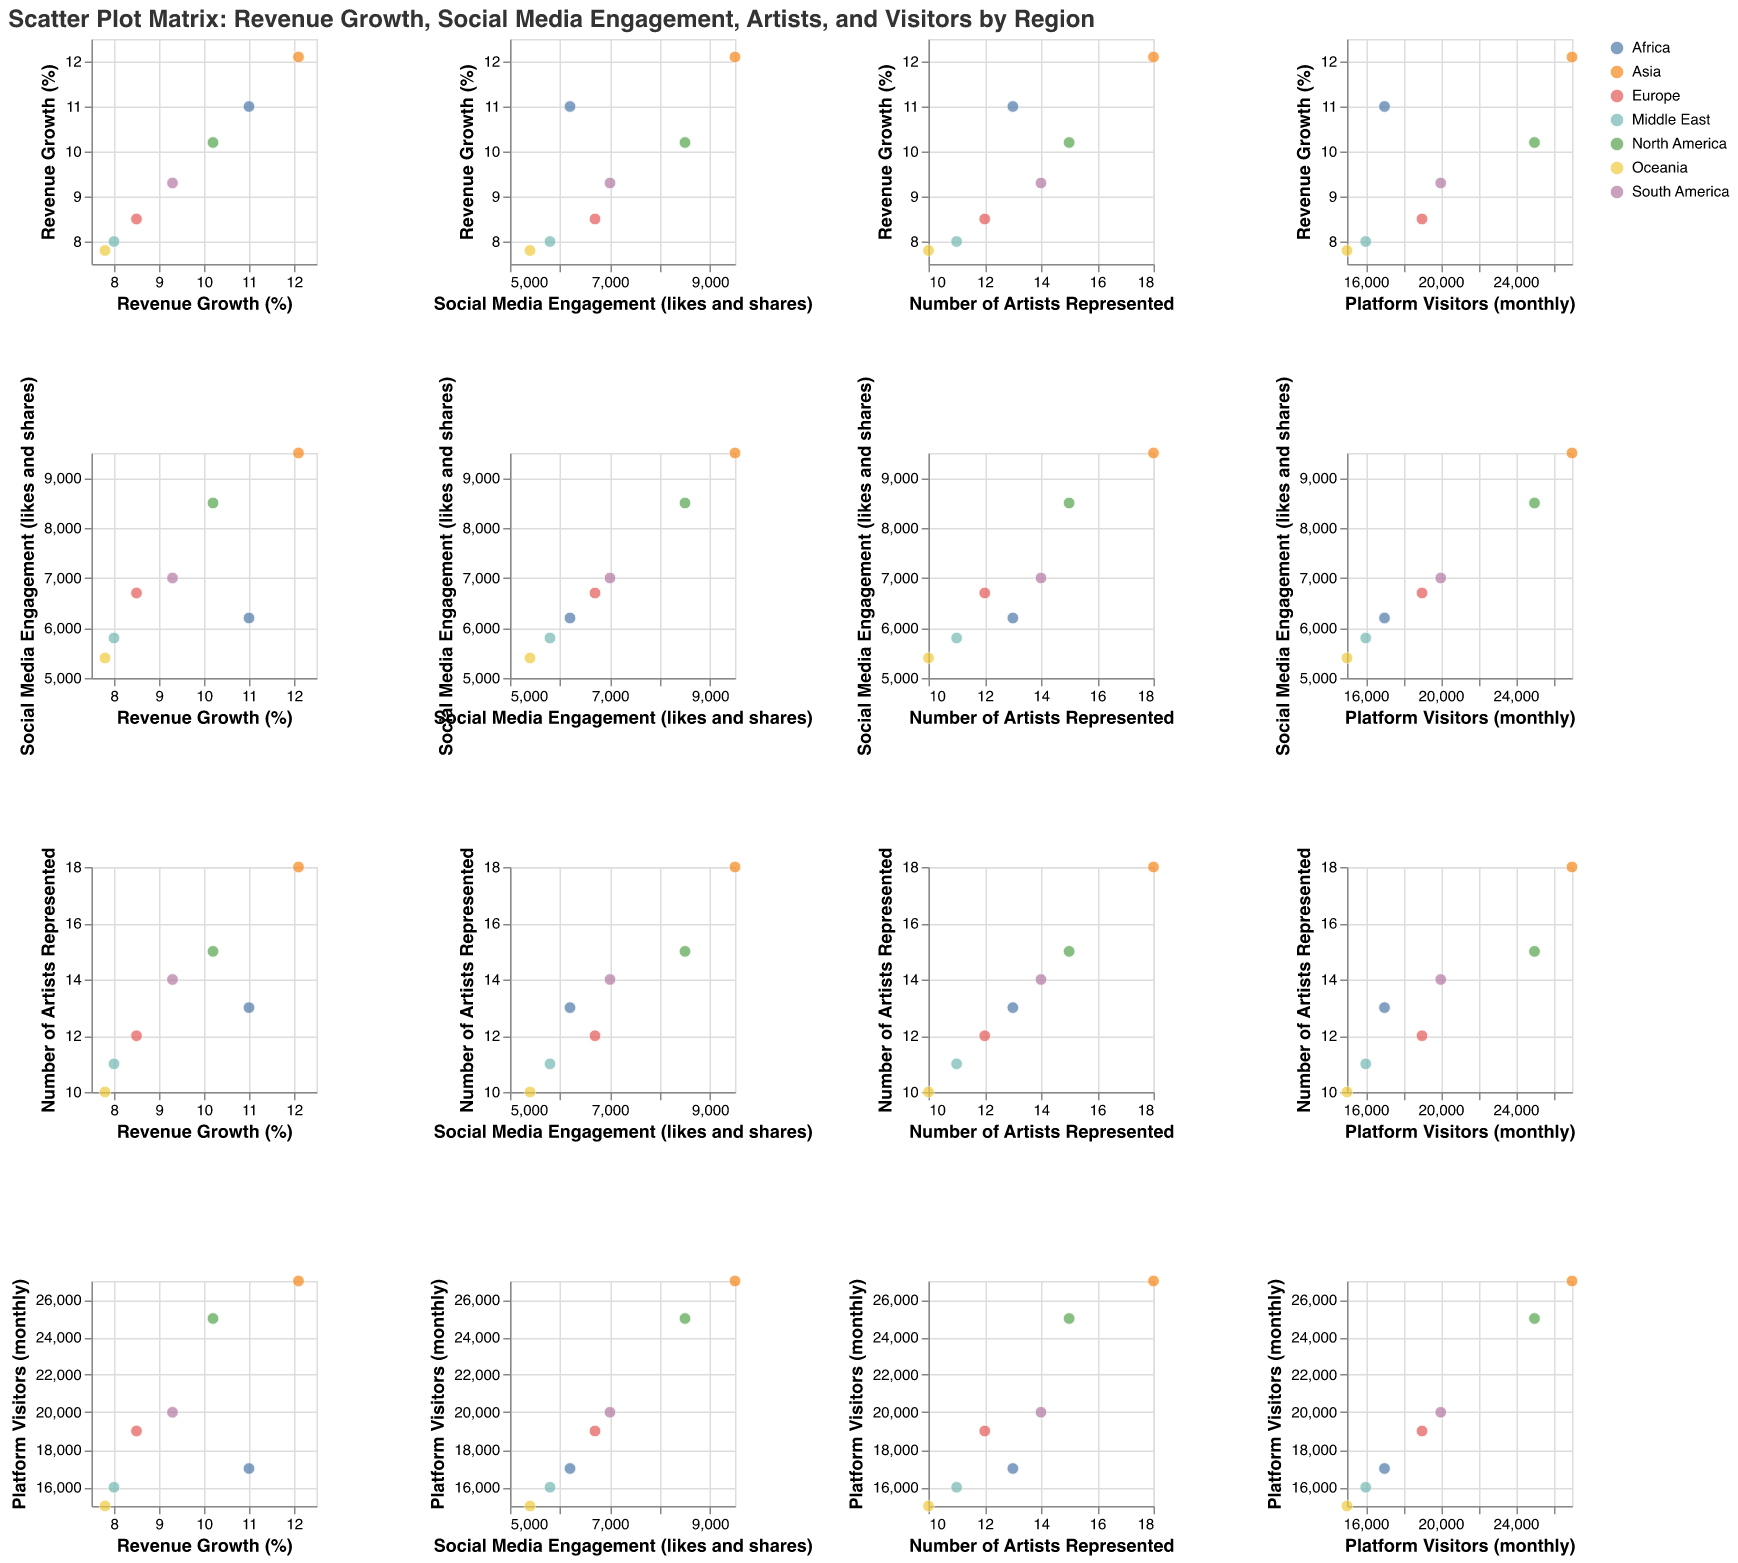What region has the highest revenue growth percentage? By looking at the scatter plot matrix, specifically the diagonal scatter plots for "Revenue Growth (%)", we can see that Asia has the highest revenue growth percentage at 12.1%.
Answer: Asia Which region has the lowest social media engagement, and what is the value? In the scatter plot matrix, looking at the diagonal section for "Social Media Engagement (likes and shares)", Oceania has the lowest social media engagement with a value of 5400.
Answer: Oceania How many regions have more than 20000 platform visitors per month? By examining the diagonal scatter plots for "Platform Visitors (monthly)", we can count the regions with more than 20000 visitors. North America (25000) and Asia (27000) are the regions with more than 20000 visitors. Therefore, there are 2 regions.
Answer: 2 What is the average number of artists represented among the regions? Look at the scatter plot for "Number of Artists Represented" diagonally. The values given are 15, 12, 18, 14, 10, 13, and 11. Summing these values: 15 + 12 + 18 + 14 + 10 + 13 + 11 = 93. Dividing by 7 (the number of regions), the average is 93/7 ≈ 13.29.
Answer: 13.29 Which region has the highest platform visitors per month but a revenue growth percentage of less than 11%? In the matrix, look at "Platform Visitors (monthly)" and cross-reference it with "Revenue Growth (%)". Asia has the highest platform visitors (27000) and its revenue growth percentage is 12.1%. Thus, it doesn't qualify. North America, with 25000 visitors, has a revenue growth percentage of 10.2%, which fits the criteria.
Answer: North America Is there a positive correlation between social media engagement and revenue growth across regions? By examining the scatter plot between "Revenue Growth (%)" and "Social Media Engagement (likes and shares)", points generally trend upwards from bottom left to top right, indicating a positive correlation.
Answer: Yes, there is a positive correlation Which region has slightly more social media engagement than Europe but less revenue growth? Checking the scatter plot, Europe has 6700 likes and shares. South America has slightly more at 7000 and a revenue growth of 9.3%, but Oceania has 5400 likes and shares. Africa, with 6200 likes and shares and a revenue growth of 11.0%, fits the criteria.
Answer: Africa 